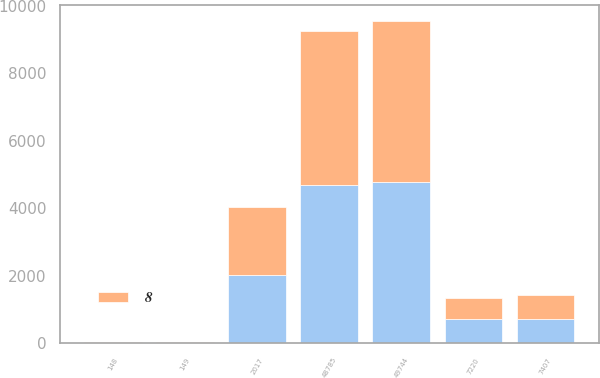Convert chart to OTSL. <chart><loc_0><loc_0><loc_500><loc_500><stacked_bar_chart><ecel><fcel>2017<fcel>48785<fcel>49744<fcel>7220<fcel>7407<fcel>148<fcel>149<nl><fcel>nan<fcel>2016<fcel>4687.2<fcel>4766.6<fcel>720<fcel>735.9<fcel>15.4<fcel>15.3<nl><fcel>8<fcel>2015<fcel>4551.1<fcel>4773.9<fcel>638.9<fcel>684.1<fcel>14<fcel>14.1<nl></chart> 